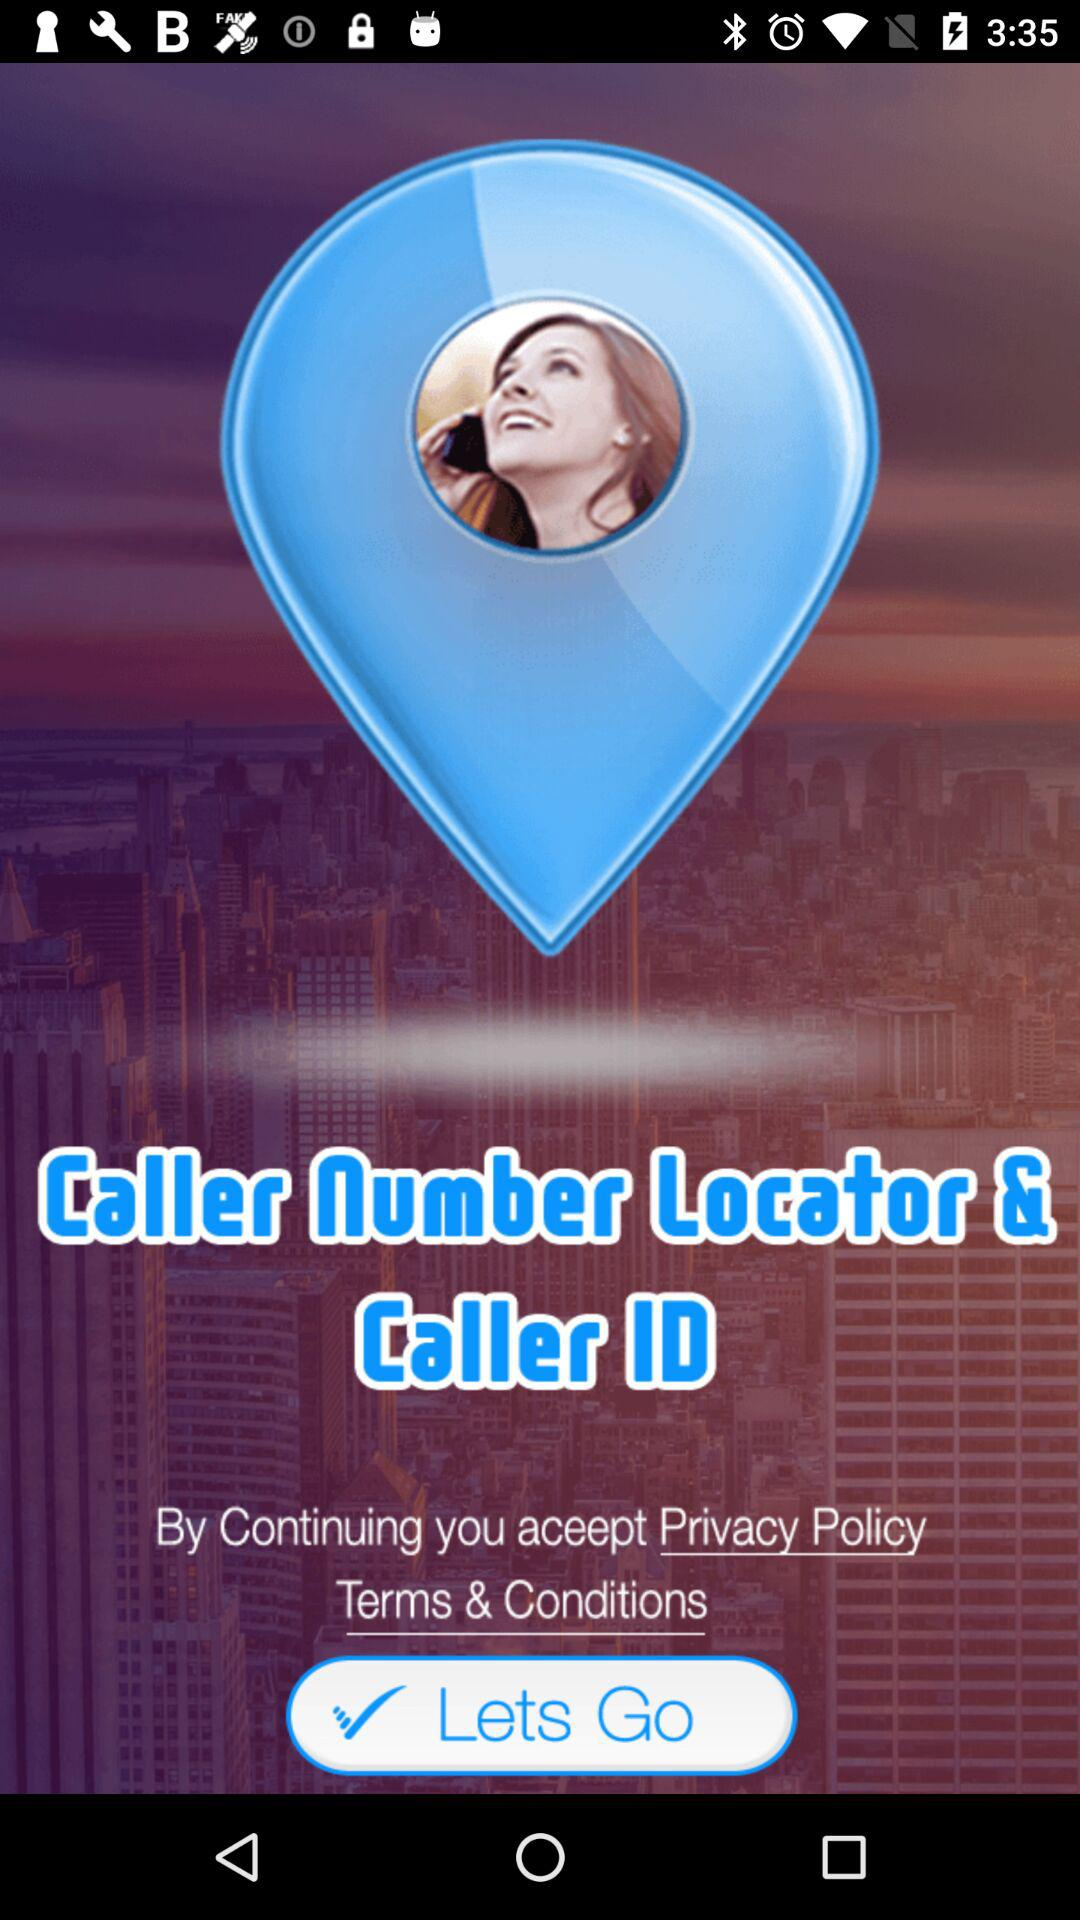What is the application name? The application name is "Caller Number Locator & Caller ID". 